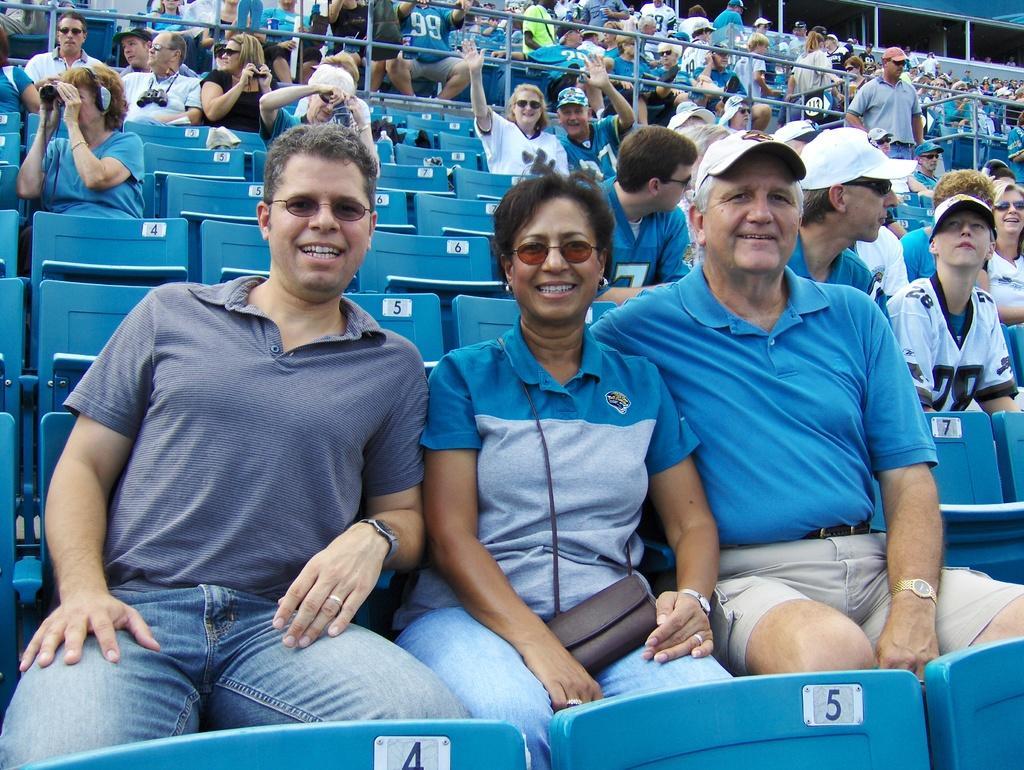Describe this image in one or two sentences. In this image, we can see persons wearing clothes and sitting on chairs. There are safety grills at the top of the image. 